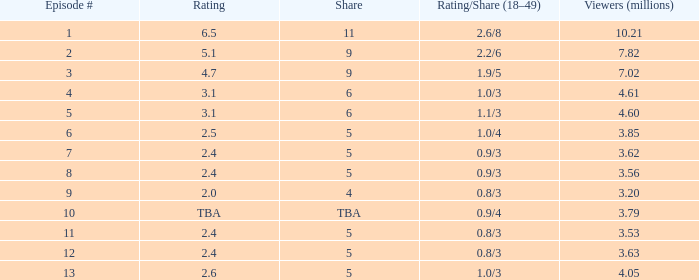What is the rating/share for episode 13? 1.0/3. 